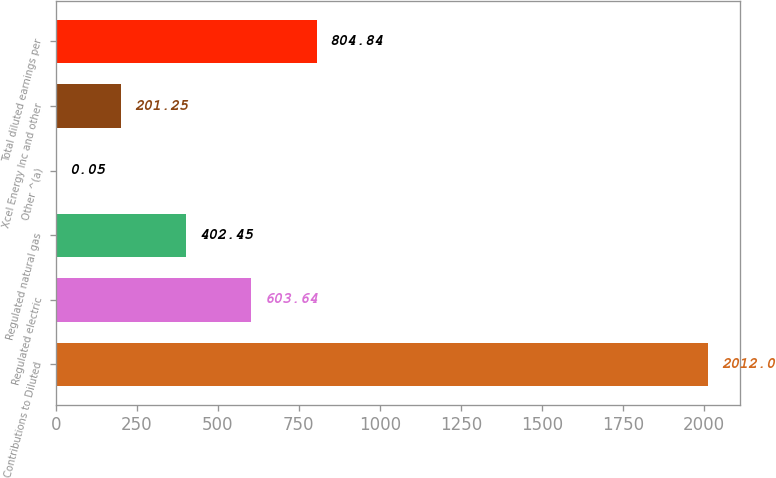Convert chart. <chart><loc_0><loc_0><loc_500><loc_500><bar_chart><fcel>Contributions to Diluted<fcel>Regulated electric<fcel>Regulated natural gas<fcel>Other ^(a)<fcel>Xcel Energy Inc and other<fcel>Total diluted earnings per<nl><fcel>2012<fcel>603.64<fcel>402.45<fcel>0.05<fcel>201.25<fcel>804.84<nl></chart> 